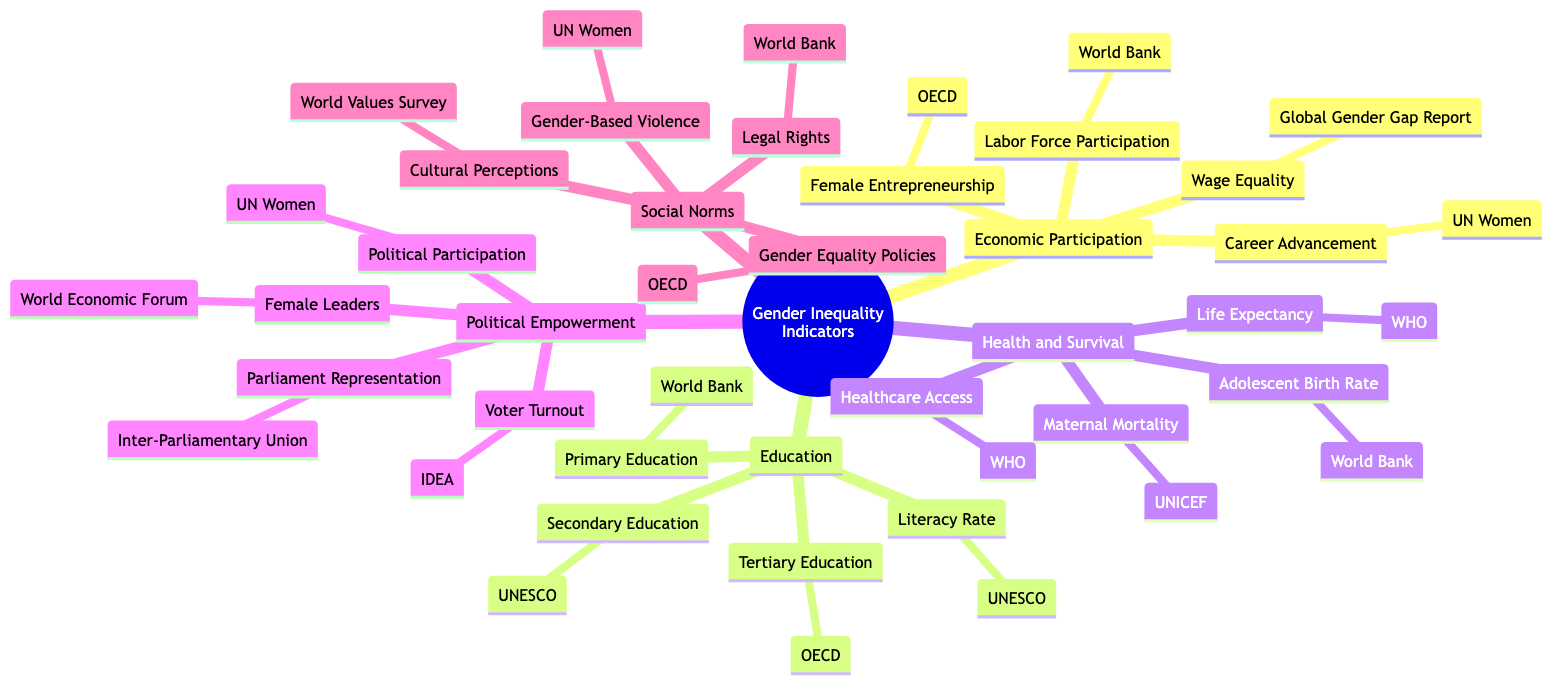What are the four main categories of gender inequality indicators? The diagram branches into four main categories: Economic Participation and Opportunity, Education, Health and Survival, Political Empowerment, and Social Norms and Attitudes. Each major section represents key areas where gender inequality can be evaluated.
Answer: Economic Participation and Opportunity, Education, Health and Survival, Political Empowerment, Social Norms and Attitudes Which organization is responsible for the Labor Force Participation Rate indicator? Under the Economic Participation and Opportunity category, the Labor Force Participation Rate is linked to the World Bank. It’s explicitly listed as the source next to this indicator.
Answer: World Bank How many indicators are listed under the Education category? The Education category consists of four indicators: Literacy Rate, Primary Education Enrollment, Secondary Education Enrollment, and Tertiary Education Enrollment, which can be counted as you navigate through this branch in the diagram.
Answer: 4 What is the source organization for the Adolescent Birth Rate? In the Health and Survival section, the Adolescent Birth Rate indicator is associated with the World Bank, which is noted alongside the indicator in the diagram.
Answer: World Bank Which indicator under Political Empowerment corresponds to female leaders, and which organization measures it? The diagram shows "Female Heads of State Government" under the Political Empowerment category, with the World Economic Forum indicated as the measuring organization next to it.
Answer: Female Heads of State Government, World Economic Forum What is the relationship between Gender-Based Violence and UN Women in the mind map structure? Gender-Based Violence is listed under the Social Norms and Attitudes category, and UN Women is the organization associated with this indicator. The connection shows UN Women’s role in addressing and measuring this issue.
Answer: UN Women How many total sources are mentioned for indicators across all categories? By counting the organizations provided for each indicator from all categories, there are six distinct sources mentioned: World Bank, Global Gender Gap Report, OECD, UN Women, UNESCO, WHO, UNICEF, International Institute for Democracy and Electoral Assistance, and the World Values Survey. The total can be calculated by noting each unique entry in the diagram.
Answer: 8 Which category includes Access to Healthcare as an indicator? Access to Healthcare is located in the Health and Survival section of the diagram, indicating that it is one of the critical health-related metrics for measuring gender inequality.
Answer: Health and Survival What type of information can be found under Social Norms and Attitudes? The Social Norms and Attitudes category summarizes key indicators such as Gender Equality Policies, Gender-Based Violence, Cultural Perceptions, and Legal Rights, highlighting societal dimensions that affect gender inequality.
Answer: Gender Equality Policies, Gender-Based Violence, Cultural Perceptions, Legal Rights 